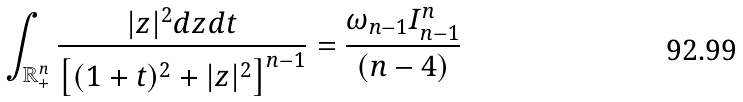<formula> <loc_0><loc_0><loc_500><loc_500>\int _ { \mathbb { R } _ { + } ^ { n } } \frac { | z | ^ { 2 } d z d t } { \left [ ( 1 + t ) ^ { 2 } + | z | ^ { 2 } \right ] ^ { n - 1 } } = \frac { \omega _ { n - 1 } I _ { n - 1 } ^ { n } } { ( n - 4 ) }</formula> 